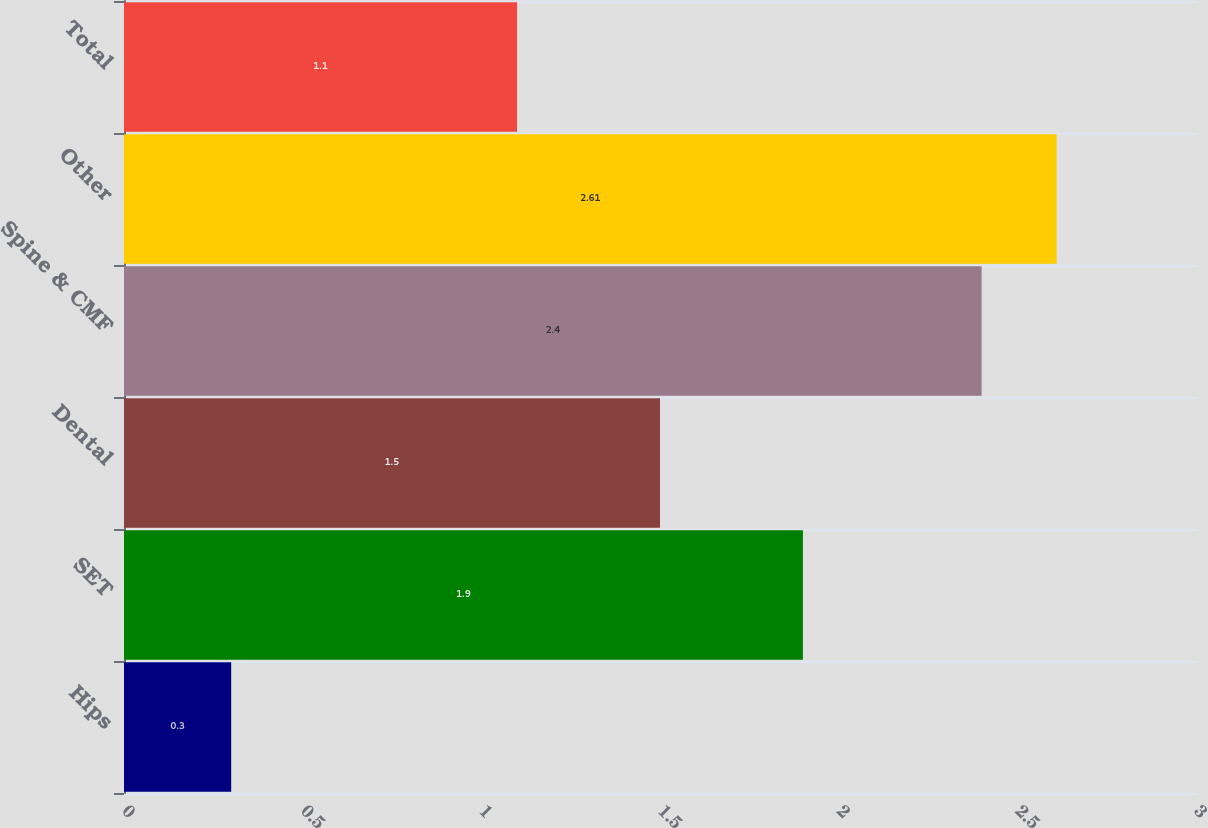Convert chart to OTSL. <chart><loc_0><loc_0><loc_500><loc_500><bar_chart><fcel>Hips<fcel>SET<fcel>Dental<fcel>Spine & CMF<fcel>Other<fcel>Total<nl><fcel>0.3<fcel>1.9<fcel>1.5<fcel>2.4<fcel>2.61<fcel>1.1<nl></chart> 